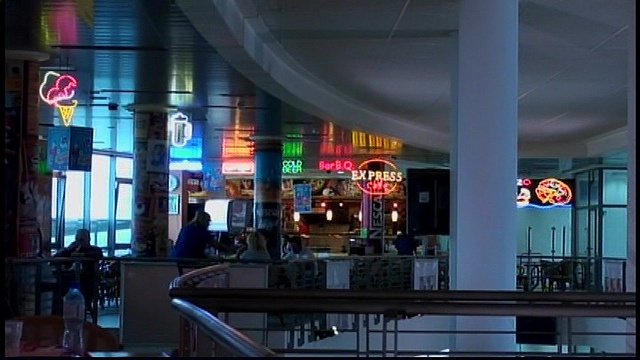Describe the objects in this image and their specific colors. I can see chair in black and darkgreen tones, chair in darkgreen, black, and gray tones, people in darkgreen, black, navy, gray, and darkblue tones, bottle in darkgreen, black, navy, gray, and darkblue tones, and chair in darkgreen, black, gray, and darkblue tones in this image. 